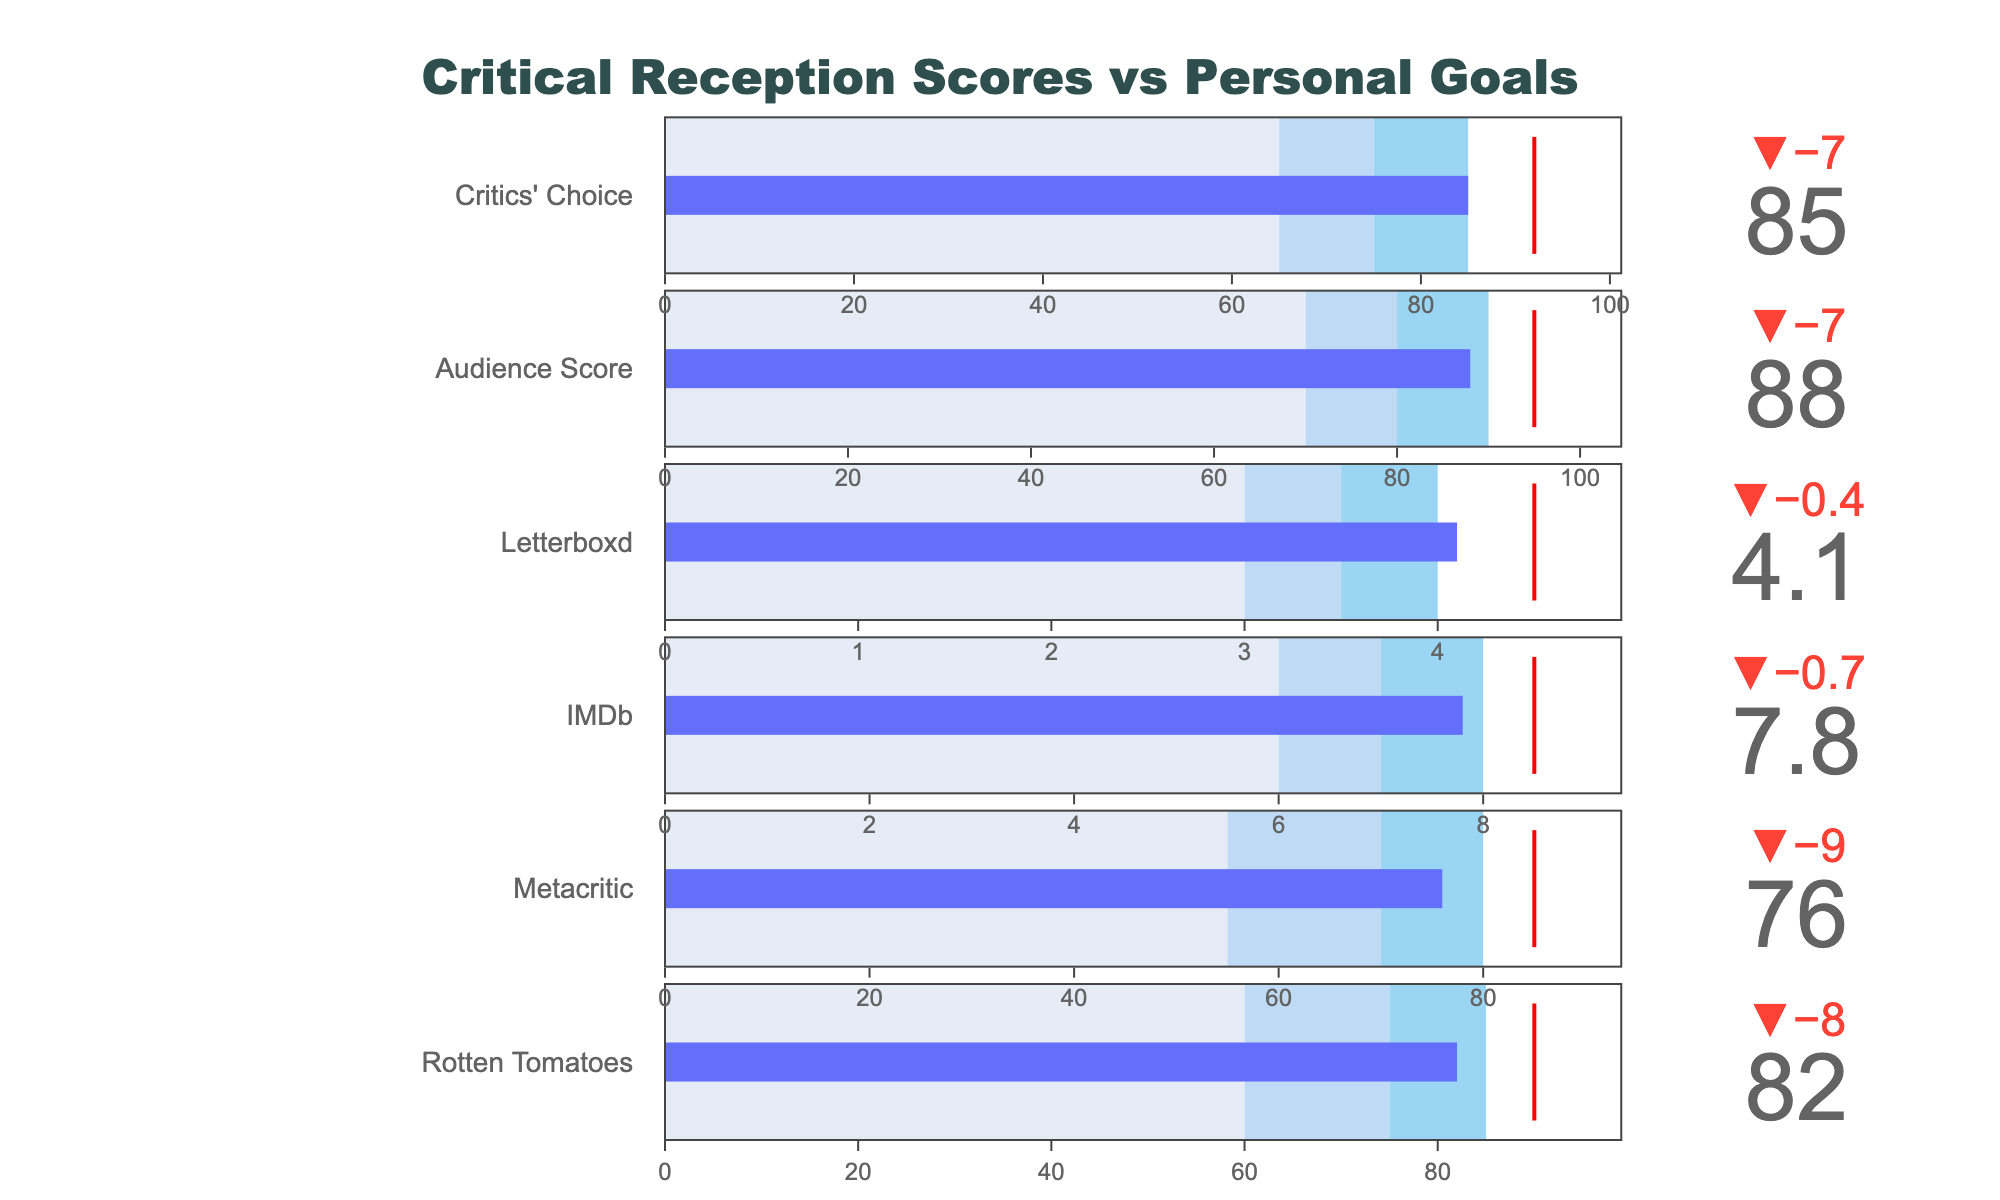What is the target score for the Rotten Tomatoes rating? The target score for each platform is indicated by the red line on the bullet chart, and for Rotten Tomatoes, the target score is listed in the data table and shown on the plot.
Answer: 90 How does the actual IMDb score compare to its target? By examining the bullet chart for IMDb, the actual score is 7.8 while the target score is 8.5, indicating the actual score is lower than the target.
Answer: The actual score is lower by 0.7 Which platform has the smallest gap between the actual and target scores? By comparing the deltas indicated by the bullet charts across all platforms, the Critics' Choice has the smallest difference with an actual of 85 and a target of 92, a gap of 7.
Answer: Critics' Choice What is the range for the audience score that represents 'satisfactory' reception? The satisfactory range is represented by the middle segment of the bullet chart, which is the Range2. For the audience score, this range is from 80 to 90.
Answer: 80 to 90 Which platform exceeds its target score the most? By observing the delta values across the bullet charts, it is clear that none of the platforms exceed their target scores, as all actual scores fall below the targets.
Answer: None What is the color-coded range for the least satisfactory critical reception scores, and which platforms fall into this range? The least satisfactory range is the first segment of each bullet chart, typically colored in a light shade. For Rotten Tomatoes, this is below 60; Metacritic below 55; IMDb below 6.0; Letterboxd below 3.0; Audience Score below 70; Critics' Choice below 65. None of the platforms fall into this least satisfactory range.
Answer: None How much higher is the actual Critics’ Choice score compared to Metacritic? Subtract the actual score for Metacritic (76) from the actual score for Critics' Choice (85) to find the difference.
Answer: 9 higher What is the title of the bullet chart plot? The title is centered at the top of the figure as displayed in the plot layout.
Answer: Critical Reception Scores vs Personal Goals Which platform has the lowest actual score, and what is it? By reviewing the bullet charts, IMDb has the lowest actual score with a value of 7.8.
Answer: IMDb, 7.8 